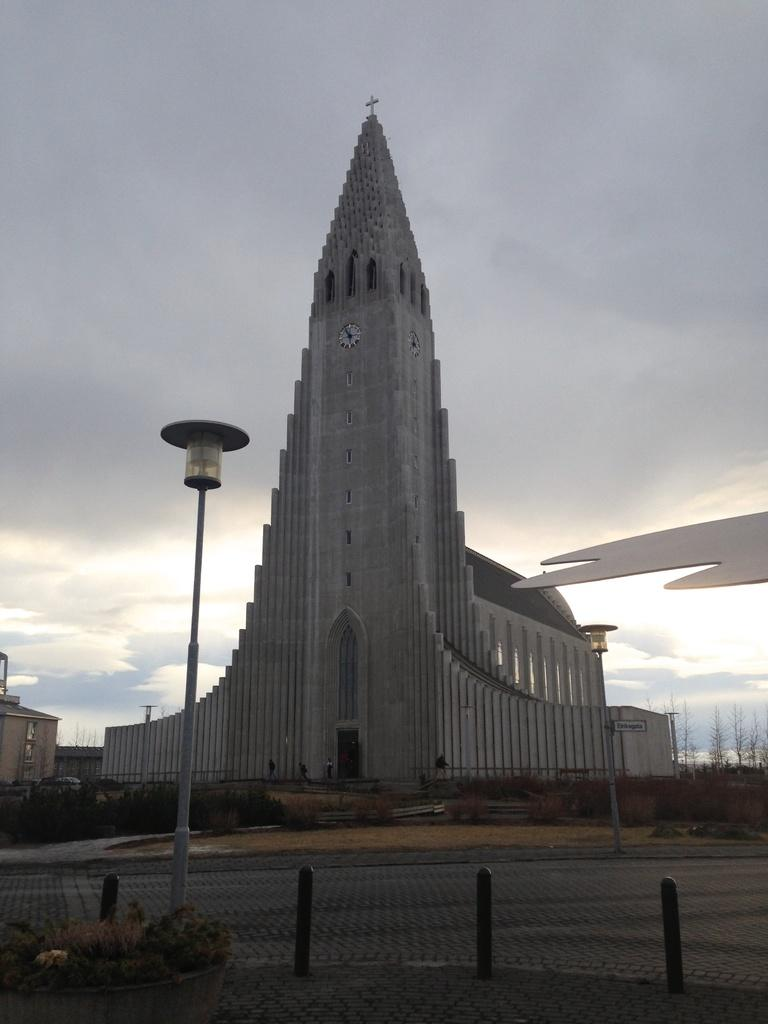What structure in the image has a clock? There is a building with a clock in the image. What type of natural elements can be seen in the image? There are trees in the image. What type of infrastructure is present on the road in the image? There is an electrical pole on the road in the image. How many bikes are parked near the trees in the image? There is no mention of bikes in the image, so we cannot determine how many there are. What part of the rabbit can be seen in the image? There are no rabbits present in the image. 